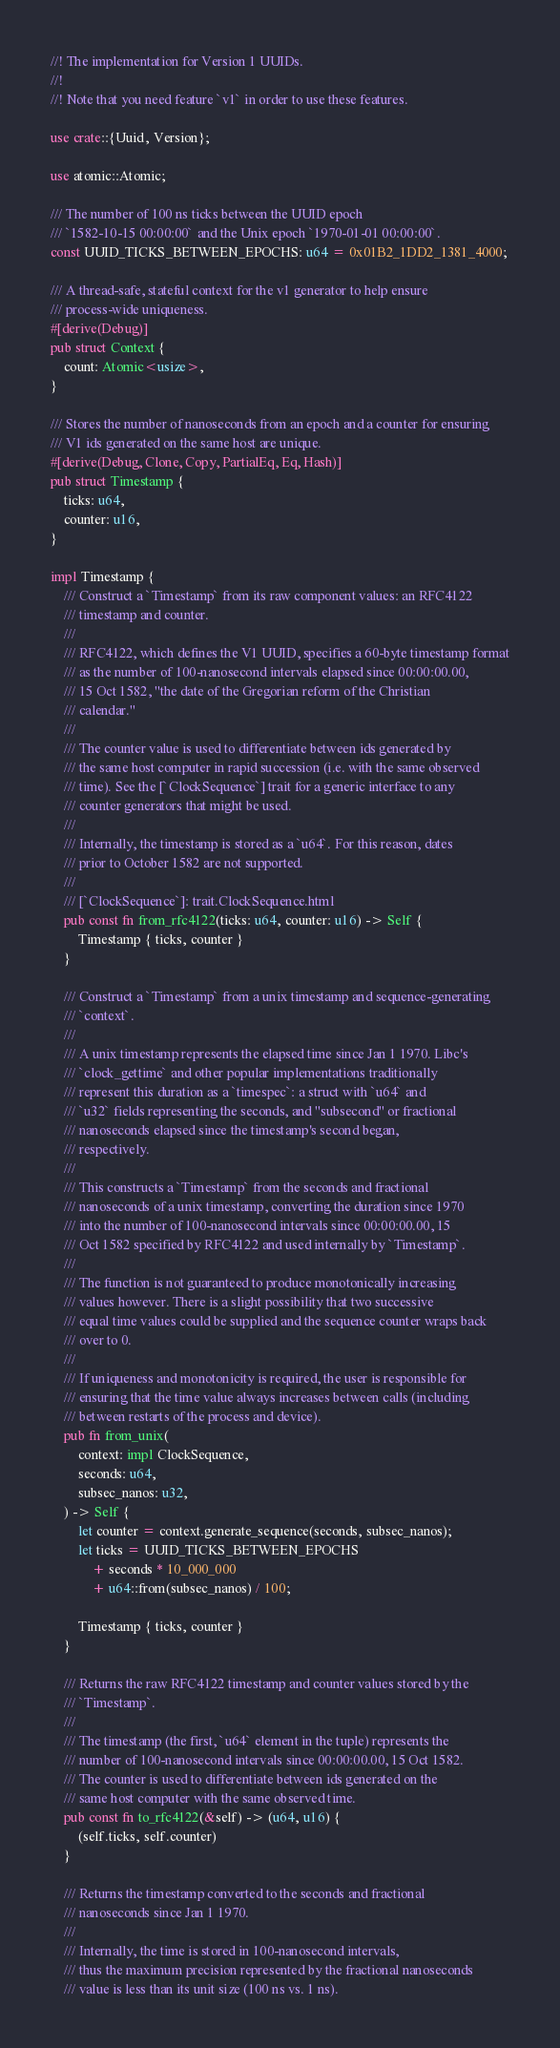Convert code to text. <code><loc_0><loc_0><loc_500><loc_500><_Rust_>//! The implementation for Version 1 UUIDs.
//!
//! Note that you need feature `v1` in order to use these features.

use crate::{Uuid, Version};

use atomic::Atomic;

/// The number of 100 ns ticks between the UUID epoch
/// `1582-10-15 00:00:00` and the Unix epoch `1970-01-01 00:00:00`.
const UUID_TICKS_BETWEEN_EPOCHS: u64 = 0x01B2_1DD2_1381_4000;

/// A thread-safe, stateful context for the v1 generator to help ensure
/// process-wide uniqueness.
#[derive(Debug)]
pub struct Context {
    count: Atomic<usize>,
}

/// Stores the number of nanoseconds from an epoch and a counter for ensuring
/// V1 ids generated on the same host are unique.
#[derive(Debug, Clone, Copy, PartialEq, Eq, Hash)]
pub struct Timestamp {
    ticks: u64,
    counter: u16,
}

impl Timestamp {
    /// Construct a `Timestamp` from its raw component values: an RFC4122
    /// timestamp and counter.
    ///
    /// RFC4122, which defines the V1 UUID, specifies a 60-byte timestamp format
    /// as the number of 100-nanosecond intervals elapsed since 00:00:00.00,
    /// 15 Oct 1582, "the date of the Gregorian reform of the Christian
    /// calendar."
    ///
    /// The counter value is used to differentiate between ids generated by
    /// the same host computer in rapid succession (i.e. with the same observed
    /// time). See the [`ClockSequence`] trait for a generic interface to any
    /// counter generators that might be used.
    ///
    /// Internally, the timestamp is stored as a `u64`. For this reason, dates
    /// prior to October 1582 are not supported.
    ///
    /// [`ClockSequence`]: trait.ClockSequence.html
    pub const fn from_rfc4122(ticks: u64, counter: u16) -> Self {
        Timestamp { ticks, counter }
    }

    /// Construct a `Timestamp` from a unix timestamp and sequence-generating
    /// `context`.
    ///
    /// A unix timestamp represents the elapsed time since Jan 1 1970. Libc's
    /// `clock_gettime` and other popular implementations traditionally
    /// represent this duration as a `timespec`: a struct with `u64` and
    /// `u32` fields representing the seconds, and "subsecond" or fractional
    /// nanoseconds elapsed since the timestamp's second began,
    /// respectively.
    ///
    /// This constructs a `Timestamp` from the seconds and fractional
    /// nanoseconds of a unix timestamp, converting the duration since 1970
    /// into the number of 100-nanosecond intervals since 00:00:00.00, 15
    /// Oct 1582 specified by RFC4122 and used internally by `Timestamp`.
    ///
    /// The function is not guaranteed to produce monotonically increasing
    /// values however. There is a slight possibility that two successive
    /// equal time values could be supplied and the sequence counter wraps back
    /// over to 0.
    ///
    /// If uniqueness and monotonicity is required, the user is responsible for
    /// ensuring that the time value always increases between calls (including
    /// between restarts of the process and device).
    pub fn from_unix(
        context: impl ClockSequence,
        seconds: u64,
        subsec_nanos: u32,
    ) -> Self {
        let counter = context.generate_sequence(seconds, subsec_nanos);
        let ticks = UUID_TICKS_BETWEEN_EPOCHS
            + seconds * 10_000_000
            + u64::from(subsec_nanos) / 100;

        Timestamp { ticks, counter }
    }

    /// Returns the raw RFC4122 timestamp and counter values stored by the
    /// `Timestamp`.
    ///
    /// The timestamp (the first, `u64` element in the tuple) represents the
    /// number of 100-nanosecond intervals since 00:00:00.00, 15 Oct 1582.
    /// The counter is used to differentiate between ids generated on the
    /// same host computer with the same observed time.
    pub const fn to_rfc4122(&self) -> (u64, u16) {
        (self.ticks, self.counter)
    }

    /// Returns the timestamp converted to the seconds and fractional
    /// nanoseconds since Jan 1 1970.
    ///
    /// Internally, the time is stored in 100-nanosecond intervals,
    /// thus the maximum precision represented by the fractional nanoseconds
    /// value is less than its unit size (100 ns vs. 1 ns).</code> 